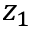Convert formula to latex. <formula><loc_0><loc_0><loc_500><loc_500>z _ { 1 }</formula> 